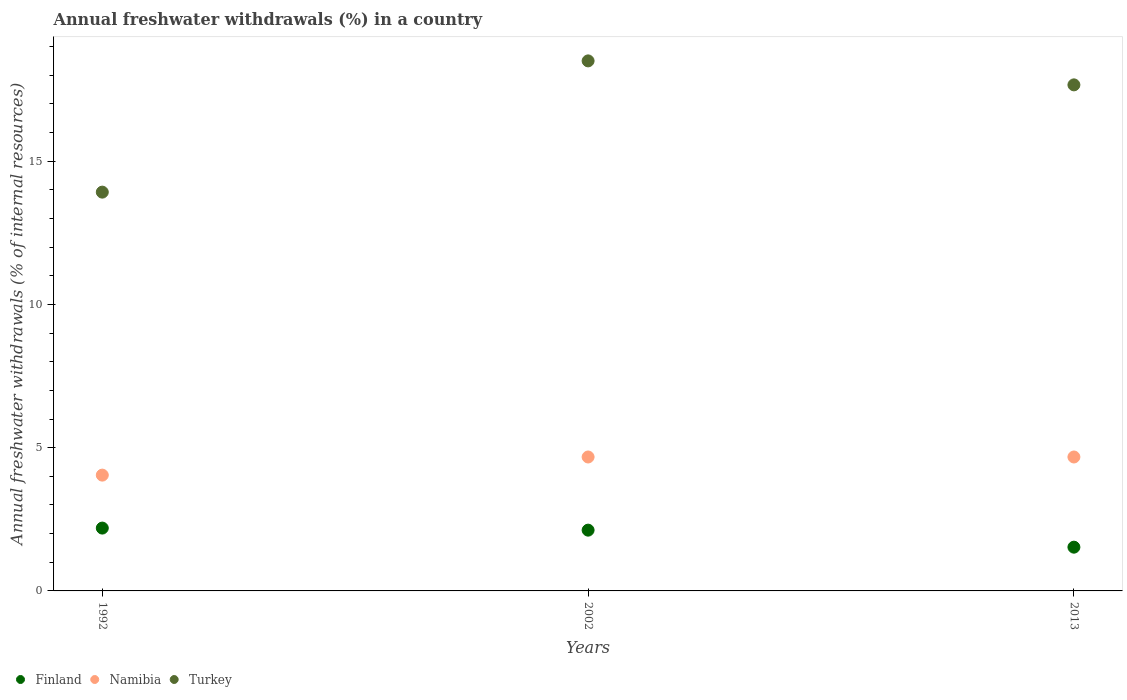How many different coloured dotlines are there?
Ensure brevity in your answer.  3. What is the percentage of annual freshwater withdrawals in Finland in 2002?
Offer a very short reply. 2.12. Across all years, what is the maximum percentage of annual freshwater withdrawals in Finland?
Make the answer very short. 2.19. Across all years, what is the minimum percentage of annual freshwater withdrawals in Finland?
Offer a terse response. 1.53. In which year was the percentage of annual freshwater withdrawals in Turkey minimum?
Give a very brief answer. 1992. What is the total percentage of annual freshwater withdrawals in Namibia in the graph?
Give a very brief answer. 13.39. What is the difference between the percentage of annual freshwater withdrawals in Namibia in 2002 and the percentage of annual freshwater withdrawals in Finland in 1992?
Offer a very short reply. 2.48. What is the average percentage of annual freshwater withdrawals in Turkey per year?
Your answer should be compact. 16.7. In the year 1992, what is the difference between the percentage of annual freshwater withdrawals in Namibia and percentage of annual freshwater withdrawals in Finland?
Keep it short and to the point. 1.85. In how many years, is the percentage of annual freshwater withdrawals in Turkey greater than 8 %?
Your answer should be very brief. 3. What is the ratio of the percentage of annual freshwater withdrawals in Turkey in 1992 to that in 2002?
Your answer should be very brief. 0.75. Is the percentage of annual freshwater withdrawals in Finland in 1992 less than that in 2002?
Your answer should be very brief. No. Is the difference between the percentage of annual freshwater withdrawals in Namibia in 1992 and 2013 greater than the difference between the percentage of annual freshwater withdrawals in Finland in 1992 and 2013?
Ensure brevity in your answer.  No. What is the difference between the highest and the lowest percentage of annual freshwater withdrawals in Turkey?
Offer a terse response. 4.58. In how many years, is the percentage of annual freshwater withdrawals in Turkey greater than the average percentage of annual freshwater withdrawals in Turkey taken over all years?
Make the answer very short. 2. Is the sum of the percentage of annual freshwater withdrawals in Namibia in 2002 and 2013 greater than the maximum percentage of annual freshwater withdrawals in Turkey across all years?
Keep it short and to the point. No. Is it the case that in every year, the sum of the percentage of annual freshwater withdrawals in Finland and percentage of annual freshwater withdrawals in Turkey  is greater than the percentage of annual freshwater withdrawals in Namibia?
Your response must be concise. Yes. Is the percentage of annual freshwater withdrawals in Turkey strictly greater than the percentage of annual freshwater withdrawals in Finland over the years?
Keep it short and to the point. Yes. How many dotlines are there?
Your answer should be compact. 3. What is the difference between two consecutive major ticks on the Y-axis?
Make the answer very short. 5. Does the graph contain any zero values?
Make the answer very short. No. Does the graph contain grids?
Give a very brief answer. No. How many legend labels are there?
Keep it short and to the point. 3. How are the legend labels stacked?
Make the answer very short. Horizontal. What is the title of the graph?
Provide a succinct answer. Annual freshwater withdrawals (%) in a country. What is the label or title of the X-axis?
Your answer should be very brief. Years. What is the label or title of the Y-axis?
Give a very brief answer. Annual freshwater withdrawals (% of internal resources). What is the Annual freshwater withdrawals (% of internal resources) of Finland in 1992?
Make the answer very short. 2.19. What is the Annual freshwater withdrawals (% of internal resources) of Namibia in 1992?
Give a very brief answer. 4.04. What is the Annual freshwater withdrawals (% of internal resources) in Turkey in 1992?
Offer a terse response. 13.92. What is the Annual freshwater withdrawals (% of internal resources) in Finland in 2002?
Keep it short and to the point. 2.12. What is the Annual freshwater withdrawals (% of internal resources) of Namibia in 2002?
Ensure brevity in your answer.  4.68. What is the Annual freshwater withdrawals (% of internal resources) of Turkey in 2002?
Your response must be concise. 18.5. What is the Annual freshwater withdrawals (% of internal resources) in Finland in 2013?
Your answer should be compact. 1.53. What is the Annual freshwater withdrawals (% of internal resources) of Namibia in 2013?
Your response must be concise. 4.68. What is the Annual freshwater withdrawals (% of internal resources) of Turkey in 2013?
Give a very brief answer. 17.67. Across all years, what is the maximum Annual freshwater withdrawals (% of internal resources) of Finland?
Your answer should be compact. 2.19. Across all years, what is the maximum Annual freshwater withdrawals (% of internal resources) in Namibia?
Your answer should be very brief. 4.68. Across all years, what is the maximum Annual freshwater withdrawals (% of internal resources) in Turkey?
Offer a very short reply. 18.5. Across all years, what is the minimum Annual freshwater withdrawals (% of internal resources) in Finland?
Keep it short and to the point. 1.53. Across all years, what is the minimum Annual freshwater withdrawals (% of internal resources) of Namibia?
Your answer should be very brief. 4.04. Across all years, what is the minimum Annual freshwater withdrawals (% of internal resources) in Turkey?
Keep it short and to the point. 13.92. What is the total Annual freshwater withdrawals (% of internal resources) in Finland in the graph?
Ensure brevity in your answer.  5.84. What is the total Annual freshwater withdrawals (% of internal resources) of Namibia in the graph?
Provide a succinct answer. 13.39. What is the total Annual freshwater withdrawals (% of internal resources) in Turkey in the graph?
Keep it short and to the point. 50.09. What is the difference between the Annual freshwater withdrawals (% of internal resources) of Finland in 1992 and that in 2002?
Offer a terse response. 0.07. What is the difference between the Annual freshwater withdrawals (% of internal resources) of Namibia in 1992 and that in 2002?
Offer a very short reply. -0.63. What is the difference between the Annual freshwater withdrawals (% of internal resources) in Turkey in 1992 and that in 2002?
Your answer should be very brief. -4.58. What is the difference between the Annual freshwater withdrawals (% of internal resources) of Finland in 1992 and that in 2013?
Provide a succinct answer. 0.67. What is the difference between the Annual freshwater withdrawals (% of internal resources) of Namibia in 1992 and that in 2013?
Your response must be concise. -0.63. What is the difference between the Annual freshwater withdrawals (% of internal resources) of Turkey in 1992 and that in 2013?
Offer a terse response. -3.74. What is the difference between the Annual freshwater withdrawals (% of internal resources) in Finland in 2002 and that in 2013?
Provide a succinct answer. 0.59. What is the difference between the Annual freshwater withdrawals (% of internal resources) of Turkey in 2002 and that in 2013?
Your answer should be very brief. 0.84. What is the difference between the Annual freshwater withdrawals (% of internal resources) of Finland in 1992 and the Annual freshwater withdrawals (% of internal resources) of Namibia in 2002?
Offer a very short reply. -2.48. What is the difference between the Annual freshwater withdrawals (% of internal resources) in Finland in 1992 and the Annual freshwater withdrawals (% of internal resources) in Turkey in 2002?
Your response must be concise. -16.31. What is the difference between the Annual freshwater withdrawals (% of internal resources) of Namibia in 1992 and the Annual freshwater withdrawals (% of internal resources) of Turkey in 2002?
Your response must be concise. -14.46. What is the difference between the Annual freshwater withdrawals (% of internal resources) of Finland in 1992 and the Annual freshwater withdrawals (% of internal resources) of Namibia in 2013?
Provide a succinct answer. -2.48. What is the difference between the Annual freshwater withdrawals (% of internal resources) of Finland in 1992 and the Annual freshwater withdrawals (% of internal resources) of Turkey in 2013?
Your answer should be very brief. -15.47. What is the difference between the Annual freshwater withdrawals (% of internal resources) in Namibia in 1992 and the Annual freshwater withdrawals (% of internal resources) in Turkey in 2013?
Make the answer very short. -13.62. What is the difference between the Annual freshwater withdrawals (% of internal resources) of Finland in 2002 and the Annual freshwater withdrawals (% of internal resources) of Namibia in 2013?
Offer a very short reply. -2.55. What is the difference between the Annual freshwater withdrawals (% of internal resources) in Finland in 2002 and the Annual freshwater withdrawals (% of internal resources) in Turkey in 2013?
Provide a short and direct response. -15.54. What is the difference between the Annual freshwater withdrawals (% of internal resources) of Namibia in 2002 and the Annual freshwater withdrawals (% of internal resources) of Turkey in 2013?
Offer a terse response. -12.99. What is the average Annual freshwater withdrawals (% of internal resources) of Finland per year?
Ensure brevity in your answer.  1.95. What is the average Annual freshwater withdrawals (% of internal resources) of Namibia per year?
Your answer should be compact. 4.46. What is the average Annual freshwater withdrawals (% of internal resources) in Turkey per year?
Your response must be concise. 16.7. In the year 1992, what is the difference between the Annual freshwater withdrawals (% of internal resources) of Finland and Annual freshwater withdrawals (% of internal resources) of Namibia?
Your answer should be very brief. -1.85. In the year 1992, what is the difference between the Annual freshwater withdrawals (% of internal resources) of Finland and Annual freshwater withdrawals (% of internal resources) of Turkey?
Your answer should be compact. -11.73. In the year 1992, what is the difference between the Annual freshwater withdrawals (% of internal resources) in Namibia and Annual freshwater withdrawals (% of internal resources) in Turkey?
Make the answer very short. -9.88. In the year 2002, what is the difference between the Annual freshwater withdrawals (% of internal resources) in Finland and Annual freshwater withdrawals (% of internal resources) in Namibia?
Your answer should be very brief. -2.55. In the year 2002, what is the difference between the Annual freshwater withdrawals (% of internal resources) in Finland and Annual freshwater withdrawals (% of internal resources) in Turkey?
Your answer should be very brief. -16.38. In the year 2002, what is the difference between the Annual freshwater withdrawals (% of internal resources) in Namibia and Annual freshwater withdrawals (% of internal resources) in Turkey?
Your response must be concise. -13.83. In the year 2013, what is the difference between the Annual freshwater withdrawals (% of internal resources) of Finland and Annual freshwater withdrawals (% of internal resources) of Namibia?
Give a very brief answer. -3.15. In the year 2013, what is the difference between the Annual freshwater withdrawals (% of internal resources) in Finland and Annual freshwater withdrawals (% of internal resources) in Turkey?
Ensure brevity in your answer.  -16.14. In the year 2013, what is the difference between the Annual freshwater withdrawals (% of internal resources) of Namibia and Annual freshwater withdrawals (% of internal resources) of Turkey?
Make the answer very short. -12.99. What is the ratio of the Annual freshwater withdrawals (% of internal resources) of Finland in 1992 to that in 2002?
Keep it short and to the point. 1.03. What is the ratio of the Annual freshwater withdrawals (% of internal resources) of Namibia in 1992 to that in 2002?
Offer a very short reply. 0.86. What is the ratio of the Annual freshwater withdrawals (% of internal resources) of Turkey in 1992 to that in 2002?
Your answer should be very brief. 0.75. What is the ratio of the Annual freshwater withdrawals (% of internal resources) of Finland in 1992 to that in 2013?
Ensure brevity in your answer.  1.44. What is the ratio of the Annual freshwater withdrawals (% of internal resources) in Namibia in 1992 to that in 2013?
Ensure brevity in your answer.  0.86. What is the ratio of the Annual freshwater withdrawals (% of internal resources) in Turkey in 1992 to that in 2013?
Your answer should be compact. 0.79. What is the ratio of the Annual freshwater withdrawals (% of internal resources) in Finland in 2002 to that in 2013?
Your answer should be compact. 1.39. What is the ratio of the Annual freshwater withdrawals (% of internal resources) in Namibia in 2002 to that in 2013?
Keep it short and to the point. 1. What is the ratio of the Annual freshwater withdrawals (% of internal resources) of Turkey in 2002 to that in 2013?
Give a very brief answer. 1.05. What is the difference between the highest and the second highest Annual freshwater withdrawals (% of internal resources) in Finland?
Provide a short and direct response. 0.07. What is the difference between the highest and the second highest Annual freshwater withdrawals (% of internal resources) of Turkey?
Offer a very short reply. 0.84. What is the difference between the highest and the lowest Annual freshwater withdrawals (% of internal resources) in Finland?
Your answer should be very brief. 0.67. What is the difference between the highest and the lowest Annual freshwater withdrawals (% of internal resources) in Namibia?
Your response must be concise. 0.63. What is the difference between the highest and the lowest Annual freshwater withdrawals (% of internal resources) in Turkey?
Make the answer very short. 4.58. 